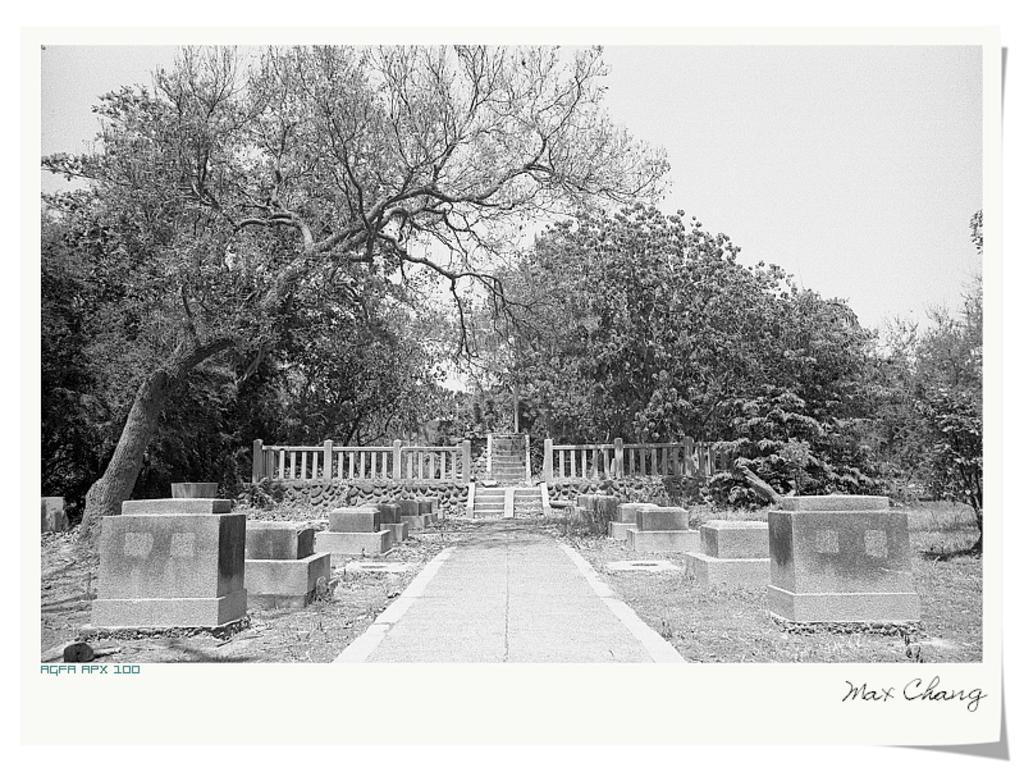Can you describe this image briefly? This is a black and white picture. In this picture we can see the sky, trees, stairs, railings, pathway and concrete blocks. At the bottom portion of the picture there is something written. 